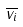<formula> <loc_0><loc_0><loc_500><loc_500>\overline { v _ { i } }</formula> 